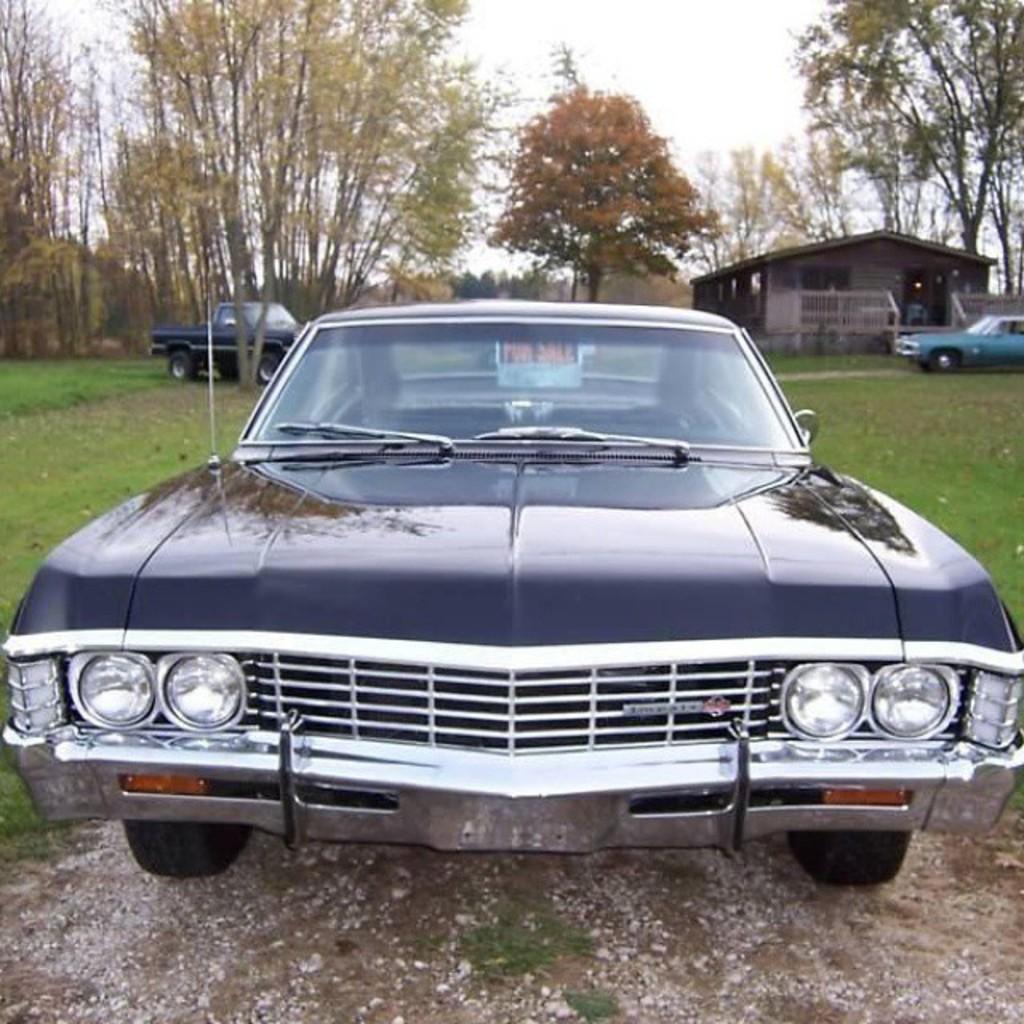Could you give a brief overview of what you see in this image? In this image in the center there is a car on the road. On the left side there's grass on the ground and there are trees in the background and there is a cottage and there are cars. The sky is cloudy. 